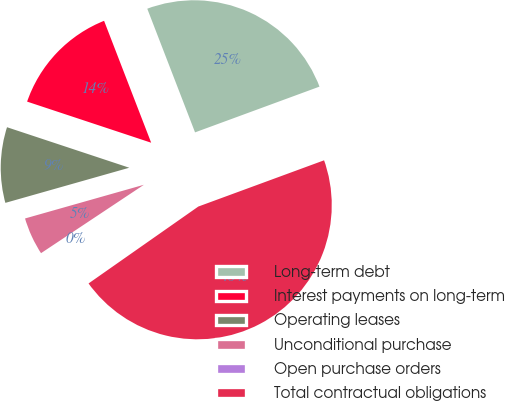<chart> <loc_0><loc_0><loc_500><loc_500><pie_chart><fcel>Long-term debt<fcel>Interest payments on long-term<fcel>Operating leases<fcel>Unconditional purchase<fcel>Open purchase orders<fcel>Total contractual obligations<nl><fcel>25.26%<fcel>14.04%<fcel>9.49%<fcel>4.94%<fcel>0.39%<fcel>45.88%<nl></chart> 